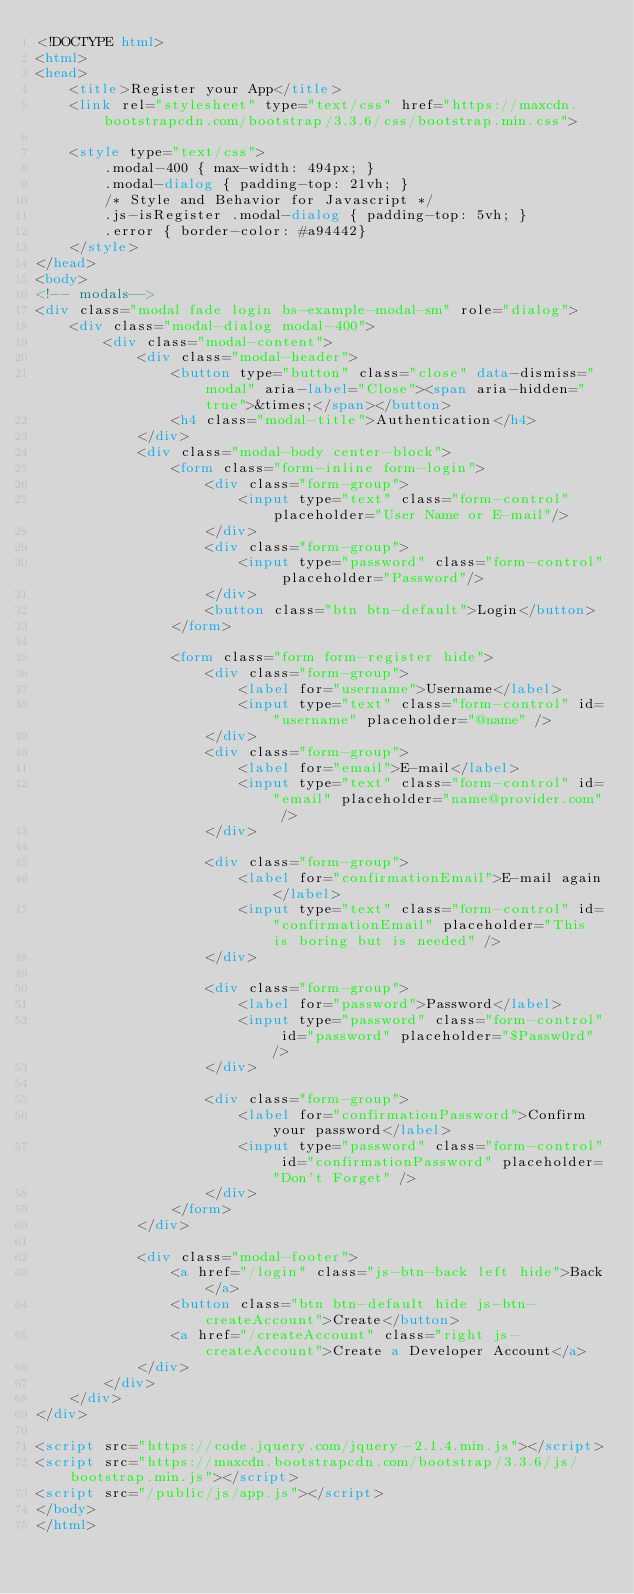Convert code to text. <code><loc_0><loc_0><loc_500><loc_500><_HTML_><!DOCTYPE html>
<html>
<head>
    <title>Register your App</title>
    <link rel="stylesheet" type="text/css" href="https://maxcdn.bootstrapcdn.com/bootstrap/3.3.6/css/bootstrap.min.css">

    <style type="text/css">
        .modal-400 { max-width: 494px; }
        .modal-dialog { padding-top: 21vh; }
        /* Style and Behavior for Javascript */
        .js-isRegister .modal-dialog { padding-top: 5vh; }
        .error { border-color: #a94442}
    </style>
</head>
<body>
<!-- modals-->
<div class="modal fade login bs-example-modal-sm" role="dialog">
    <div class="modal-dialog modal-400">
        <div class="modal-content">
            <div class="modal-header">
                <button type="button" class="close" data-dismiss="modal" aria-label="Close"><span aria-hidden="true">&times;</span></button>
                <h4 class="modal-title">Authentication</h4>
            </div>
            <div class="modal-body center-block">
                <form class="form-inline form-login">
                    <div class="form-group">
                        <input type="text" class="form-control" placeholder="User Name or E-mail"/>
                    </div>
                    <div class="form-group">
                        <input type="password" class="form-control" placeholder="Password"/>
                    </div>
                    <button class="btn btn-default">Login</button>
                </form>

                <form class="form form-register hide">
                    <div class="form-group">
                        <label for="username">Username</label>
                        <input type="text" class="form-control" id="username" placeholder="@name" />
                    </div>
                    <div class="form-group">
                        <label for="email">E-mail</label>
                        <input type="text" class="form-control" id="email" placeholder="name@provider.com" /> 
                    </div>

                    <div class="form-group">
                        <label for="confirmationEmail">E-mail again</label>
                        <input type="text" class="form-control" id="confirmationEmail" placeholder="This is boring but is needed" /> 
                    </div>

                    <div class="form-group">
                        <label for="password">Password</label>
                        <input type="password" class="form-control" id="password" placeholder="$Passw0rd" />
                    </div>

                    <div class="form-group">
                        <label for="confirmationPassword">Confirm your password</label>
                        <input type="password" class="form-control" id="confirmationPassword" placeholder="Don't Forget" />
                    </div>
                </form>
            </div>

            <div class="modal-footer">
                <a href="/login" class="js-btn-back left hide">Back</a>
                <button class="btn btn-default hide js-btn-createAccount">Create</button>
                <a href="/createAccount" class="right js-createAccount">Create a Developer Account</a>
            </div>
        </div>
    </div>
</div>

<script src="https://code.jquery.com/jquery-2.1.4.min.js"></script>
<script src="https://maxcdn.bootstrapcdn.com/bootstrap/3.3.6/js/bootstrap.min.js"></script>
<script src="/public/js/app.js"></script>
</body>
</html>
</code> 